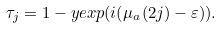<formula> <loc_0><loc_0><loc_500><loc_500>\tau _ { j } = 1 - y e x p ( i ( \mu _ { a } ( 2 j ) - \varepsilon ) ) .</formula> 